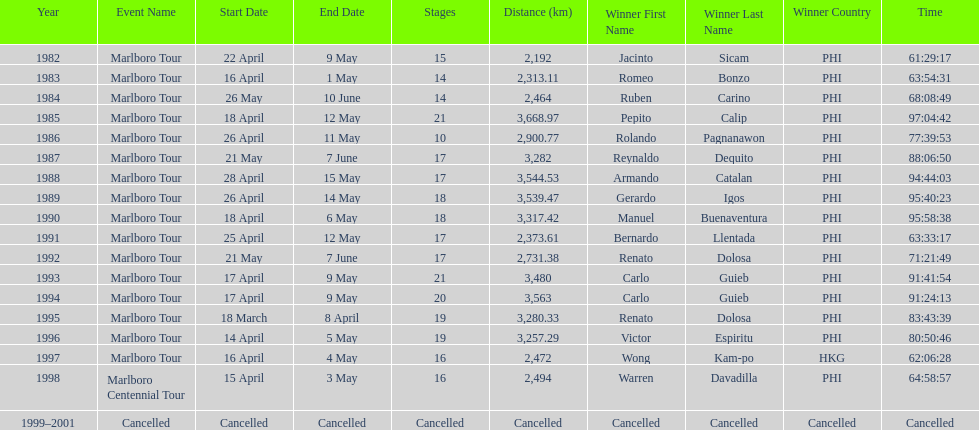How many marlboro tours did carlo guieb win? 2. 